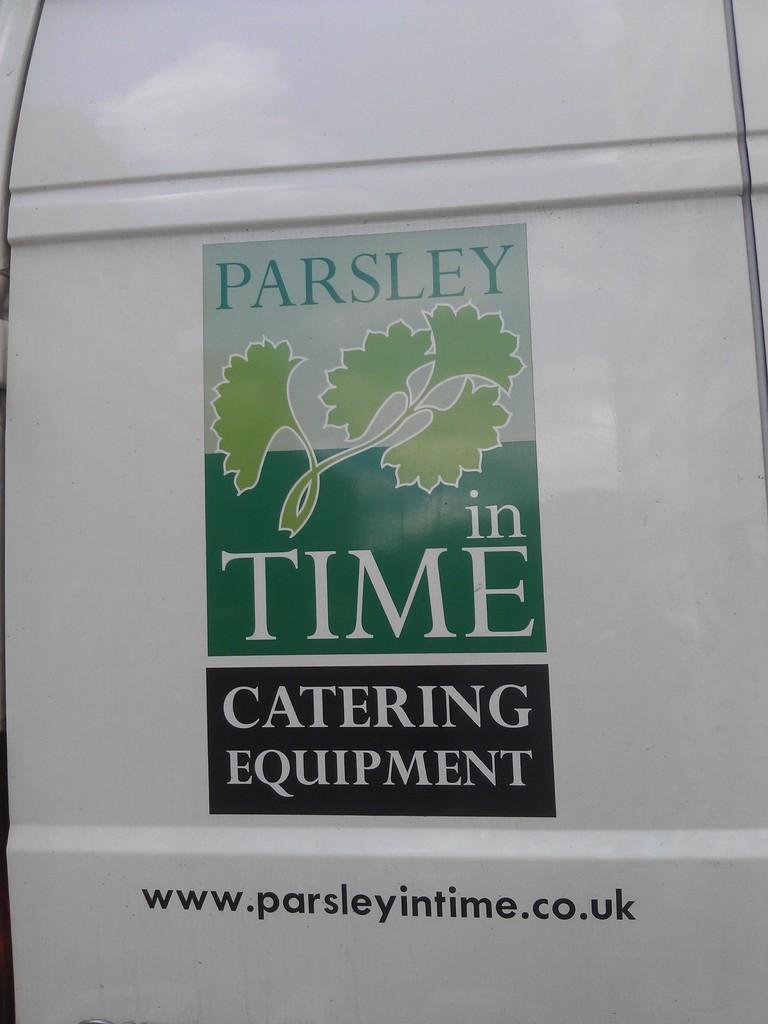Describe this image in one or two sentences. In the image we can see a logo on a vehicle. 